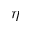Convert formula to latex. <formula><loc_0><loc_0><loc_500><loc_500>\eta</formula> 